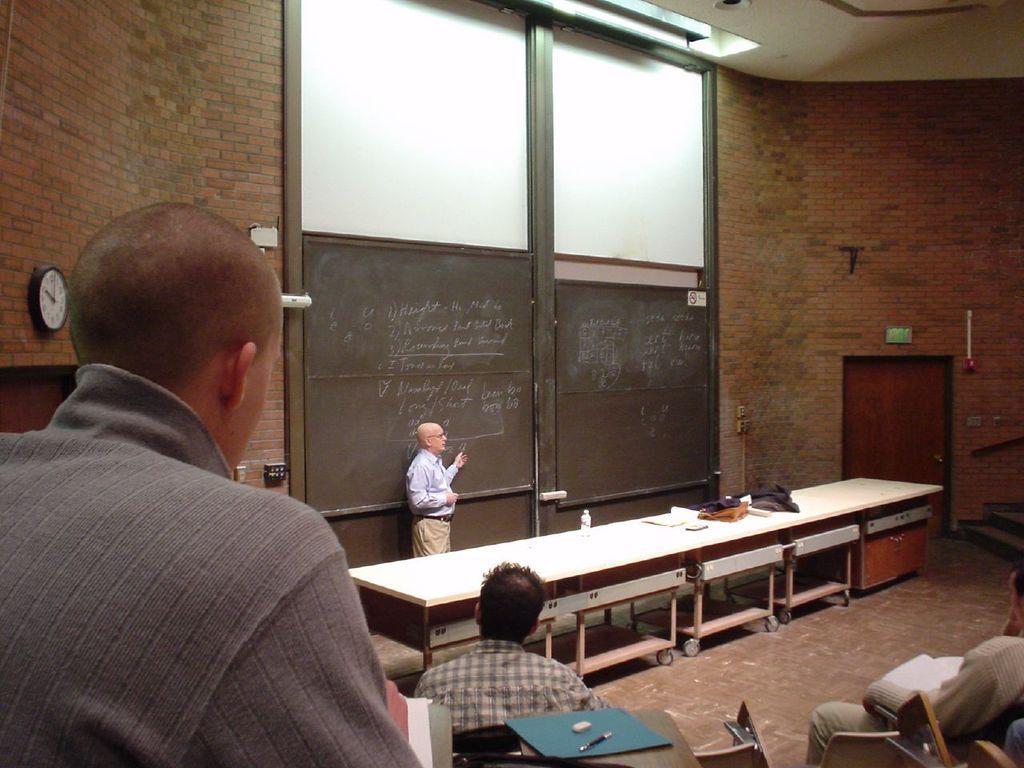How would you summarize this image in a sentence or two? In this image,There are some tables in white color,and there is a black color door, There are some people siting on the chairs and in the right side there is a wall made of bricks and in the left side there is a wall on that there is a clock which is in white color. 